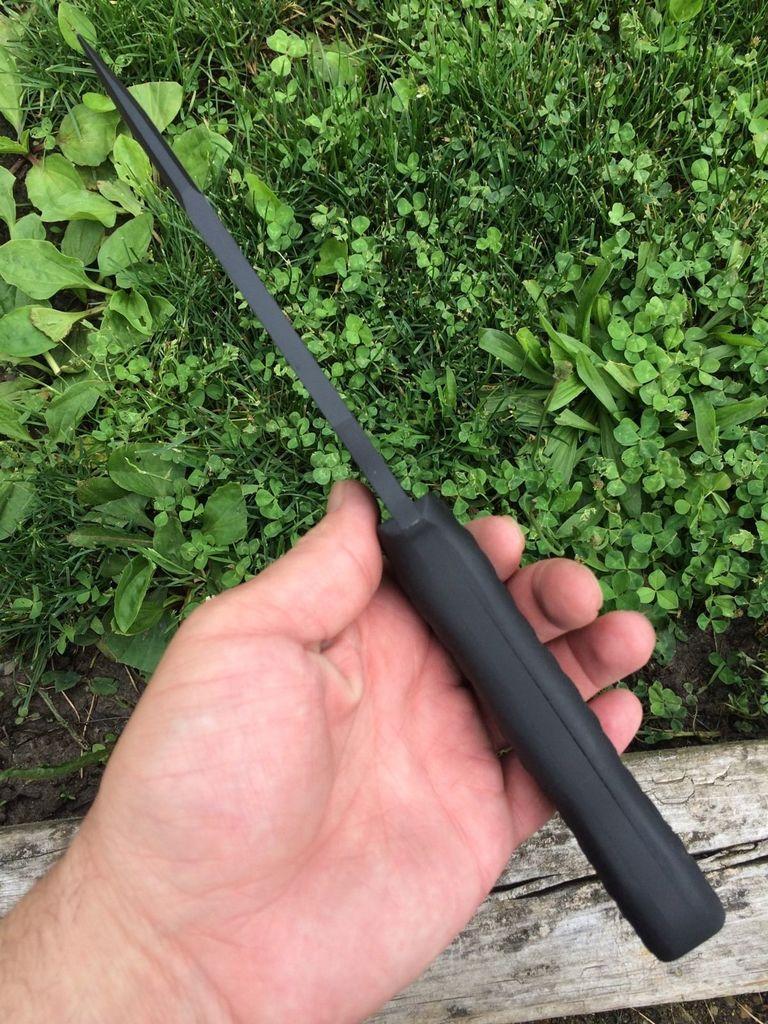How would you summarize this image in a sentence or two? In the image we can see a human hand, holding an object in hand. Here we can see the wooden stick and grass.  